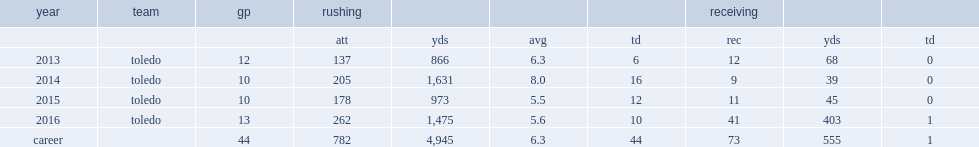How many rushing yards did kareem hunt get totally? 4945.0. Help me parse the entirety of this table. {'header': ['year', 'team', 'gp', 'rushing', '', '', '', 'receiving', '', ''], 'rows': [['', '', '', 'att', 'yds', 'avg', 'td', 'rec', 'yds', 'td'], ['2013', 'toledo', '12', '137', '866', '6.3', '6', '12', '68', '0'], ['2014', 'toledo', '10', '205', '1,631', '8.0', '16', '9', '39', '0'], ['2015', 'toledo', '10', '178', '973', '5.5', '12', '11', '45', '0'], ['2016', 'toledo', '13', '262', '1,475', '5.6', '10', '41', '403', '1'], ['career', '', '44', '782', '4,945', '6.3', '44', '73', '555', '1']]} 